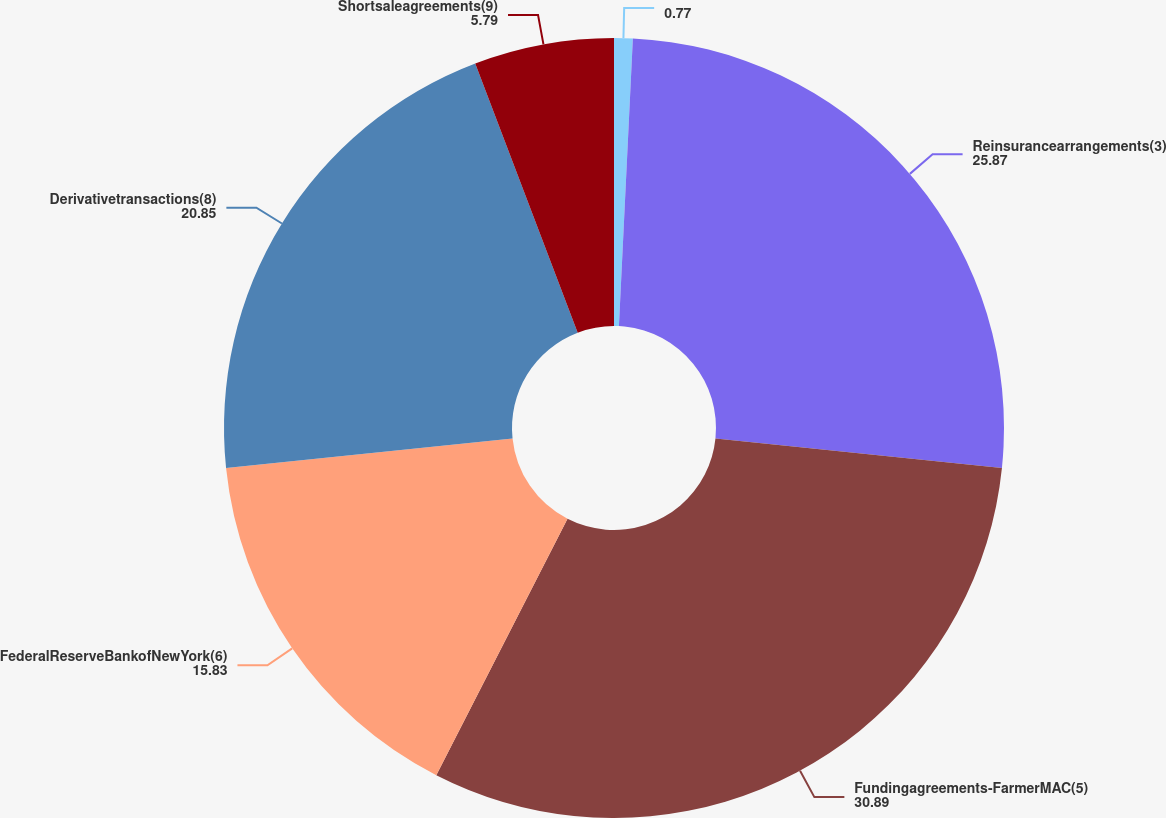Convert chart to OTSL. <chart><loc_0><loc_0><loc_500><loc_500><pie_chart><ecel><fcel>Reinsurancearrangements(3)<fcel>Fundingagreements-FarmerMAC(5)<fcel>FederalReserveBankofNewYork(6)<fcel>Derivativetransactions(8)<fcel>Shortsaleagreements(9)<nl><fcel>0.77%<fcel>25.87%<fcel>30.89%<fcel>15.83%<fcel>20.85%<fcel>5.79%<nl></chart> 